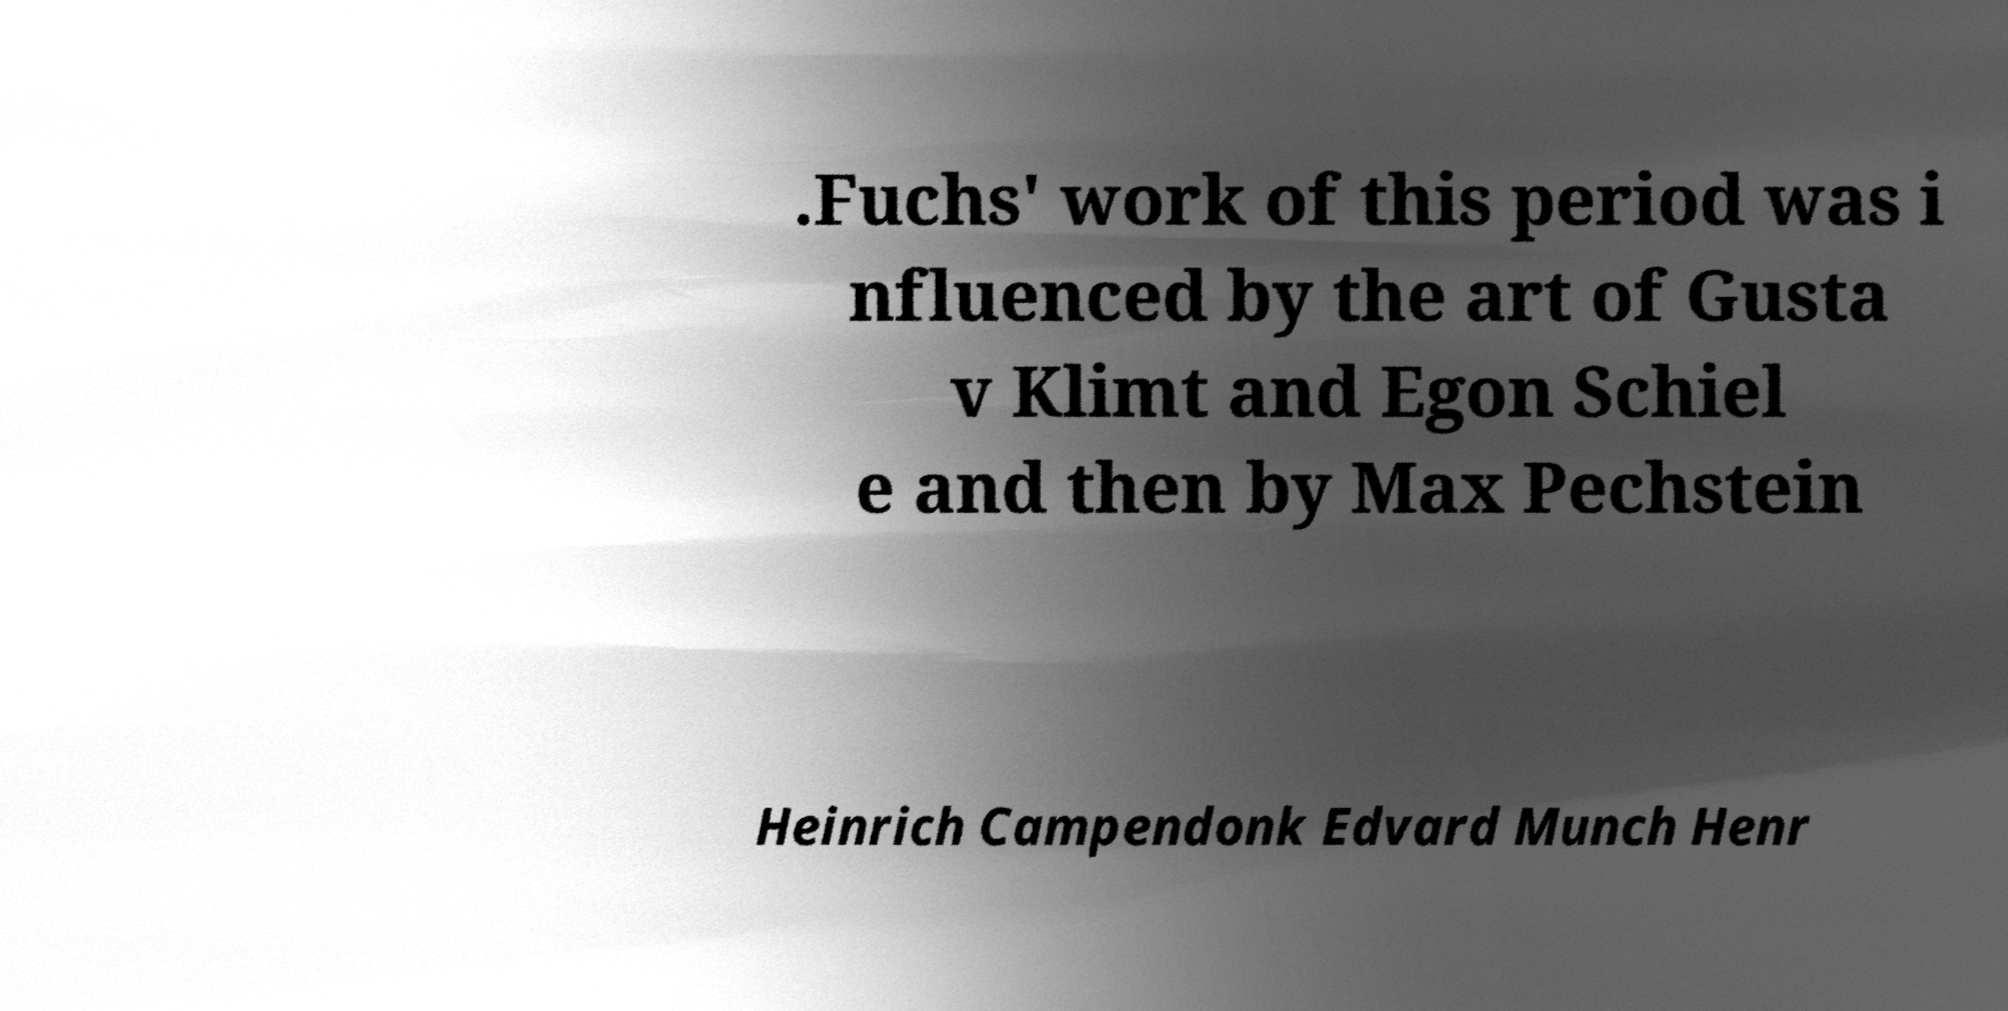Could you assist in decoding the text presented in this image and type it out clearly? .Fuchs' work of this period was i nfluenced by the art of Gusta v Klimt and Egon Schiel e and then by Max Pechstein Heinrich Campendonk Edvard Munch Henr 